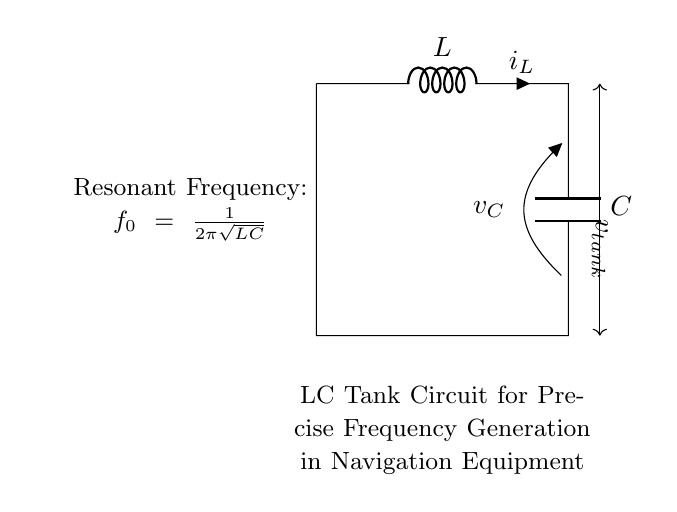What are the main components in this circuit? The main components are an inductor (L) and a capacitor (C). These elements are visible in the circuit diagram, identified by their respective symbols and labels.
Answer: Inductor and Capacitor What do the symbols L and C represent? The symbol 'L' represents an inductor, and 'C' represents a capacitor, as indicated by their labels in the circuit diagram.
Answer: Inductor and Capacitor What is the expression for resonant frequency indicated in the circuit? The circuit includes a note stating that the resonant frequency is given by the expression: f0 = 1/(2π√(LC)), as depicted in the diagram.
Answer: f0 = 1/(2π√(LC)) What type of circuit is depicted in the diagram? The diagram represents an LC tank circuit, which is specifically designed for frequency generation and is indicated by the label in the diagram.
Answer: LC tank circuit How does the energy oscillate in this LC tank circuit? In an LC tank circuit, energy oscillates between the inductor and the capacitor, as the inductor stores energy in its magnetic field and the capacitor stores energy in its electric field. This oscillation is a key characteristic of LC circuits.
Answer: Between inductor and capacitor What happens to the resonant frequency if the inductance is doubled? If the inductance is doubled, the resonant frequency decreases, as seen in the expression f0 = 1/(2π√(LC)), where an increase in L leads to a lower frequency response.
Answer: Decreases How does the tank circuit contribute to navigation accuracy? The tank circuit is used for precise frequency generation, which is critical for tuning navigation equipment such as GPS and communication systems, improving accuracy and efficiency.
Answer: Improves frequency generation 